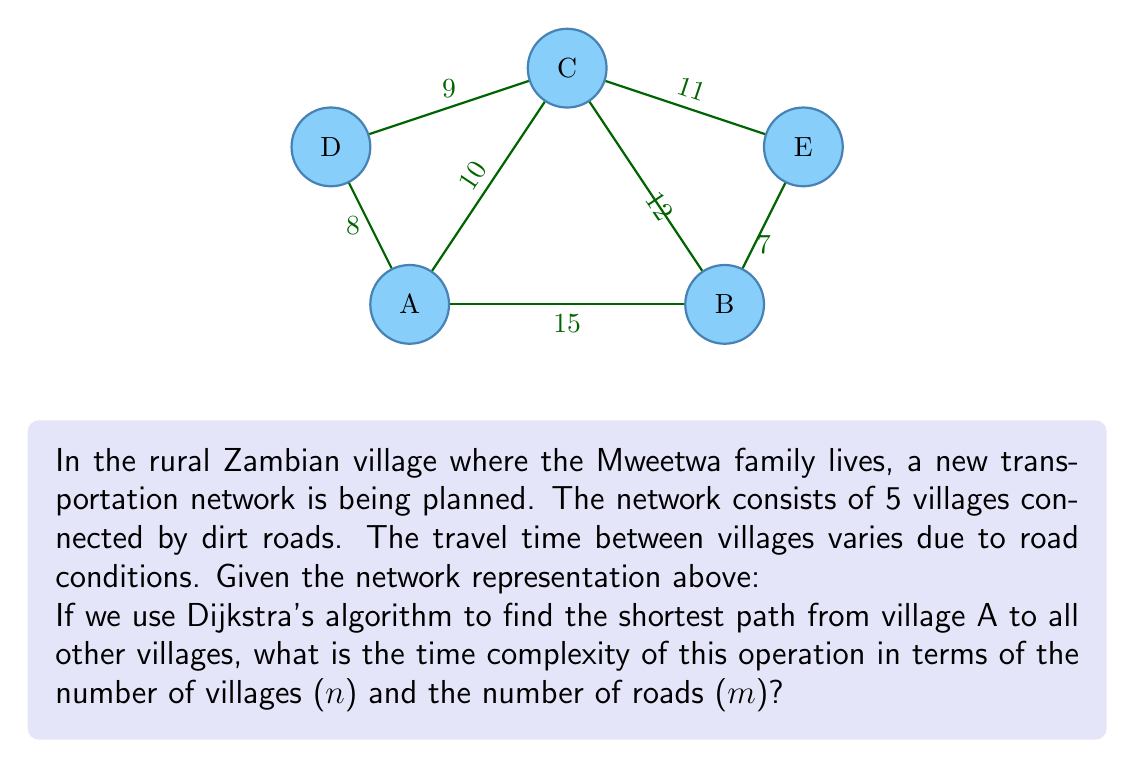Could you help me with this problem? To analyze the time complexity of Dijkstra's algorithm in this context, let's break it down step-by-step:

1) In Dijkstra's algorithm, we need to perform the following operations:
   - Initialize distances: $O(n)$
   - Extract minimum distance node: $O(n)$ (without optimization)
   - Update distances: $O(m)$ (in total, as we visit each edge once)

2) The main loop of the algorithm runs $n$ times (once for each village).

3) In each iteration, we perform:
   - Extract min: $O(n)$
   - Update distances: $O(n)$ (in the worst case, we might update all nodes)

4) Therefore, the total time complexity is:
   $O(n) + n * (O(n) + O(n)) = O(n) + O(n^2) = O(n^2)$

5) However, this can be optimized using a priority queue (min-heap):
   - Extract min becomes $O(\log n)$
   - Update distances becomes $O(\log n)$ per update

6) With a priority queue, the time complexity becomes:
   $O(n \log n + m \log n)$

7) In this specific case, we have a small, sparse graph where $m$ is close to $n$. But in general, for larger rural networks, $m$ could be larger than $n$.

Therefore, the optimized time complexity of Dijkstra's algorithm for this rural transportation network is $O((n+m) \log n)$.
Answer: $O((n+m) \log n)$ 